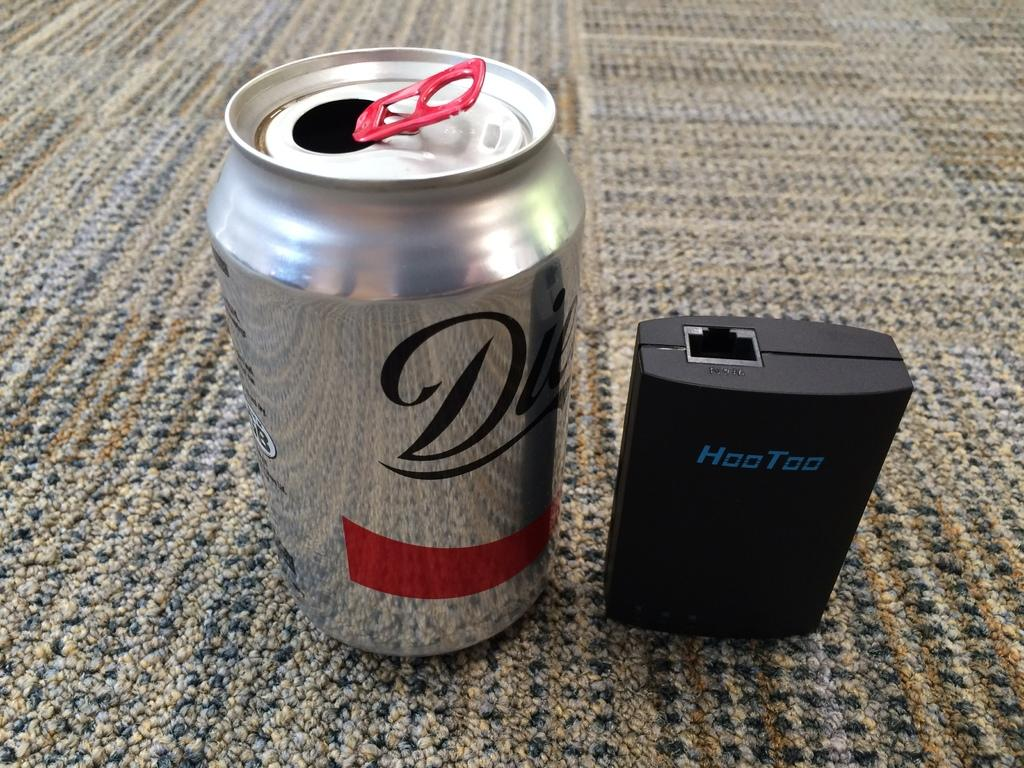<image>
Provide a brief description of the given image. The silver can of soda here happens to be diet 